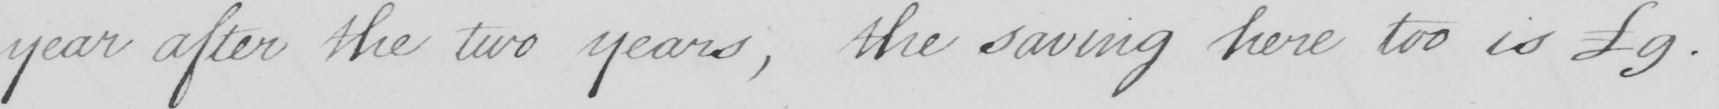What is written in this line of handwriting? year after the two years , the saving here too is 9 . 